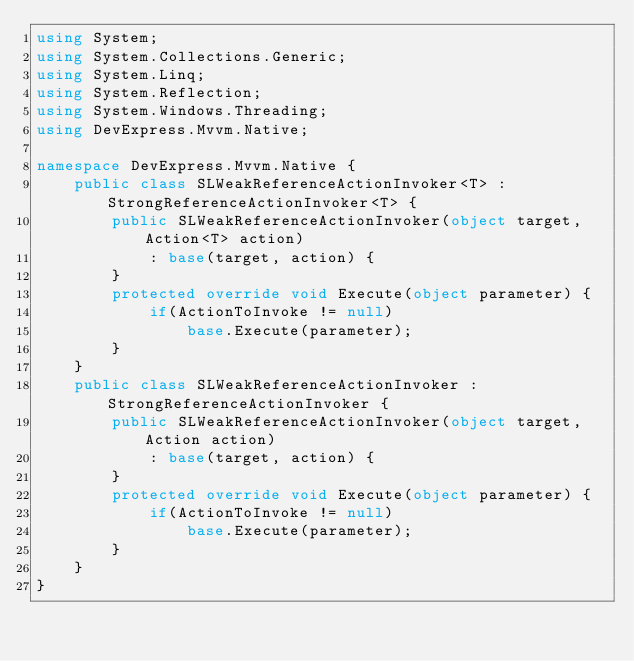Convert code to text. <code><loc_0><loc_0><loc_500><loc_500><_C#_>using System;
using System.Collections.Generic;
using System.Linq;
using System.Reflection;
using System.Windows.Threading;
using DevExpress.Mvvm.Native;

namespace DevExpress.Mvvm.Native {
    public class SLWeakReferenceActionInvoker<T> : StrongReferenceActionInvoker<T> {
        public SLWeakReferenceActionInvoker(object target, Action<T> action)
            : base(target, action) {
        }
        protected override void Execute(object parameter) {
            if(ActionToInvoke != null)
                base.Execute(parameter);
        }
    }
    public class SLWeakReferenceActionInvoker : StrongReferenceActionInvoker {
        public SLWeakReferenceActionInvoker(object target, Action action)
            : base(target, action) {
        }
        protected override void Execute(object parameter) {
            if(ActionToInvoke != null)
                base.Execute(parameter);
        }
    }
}
</code> 